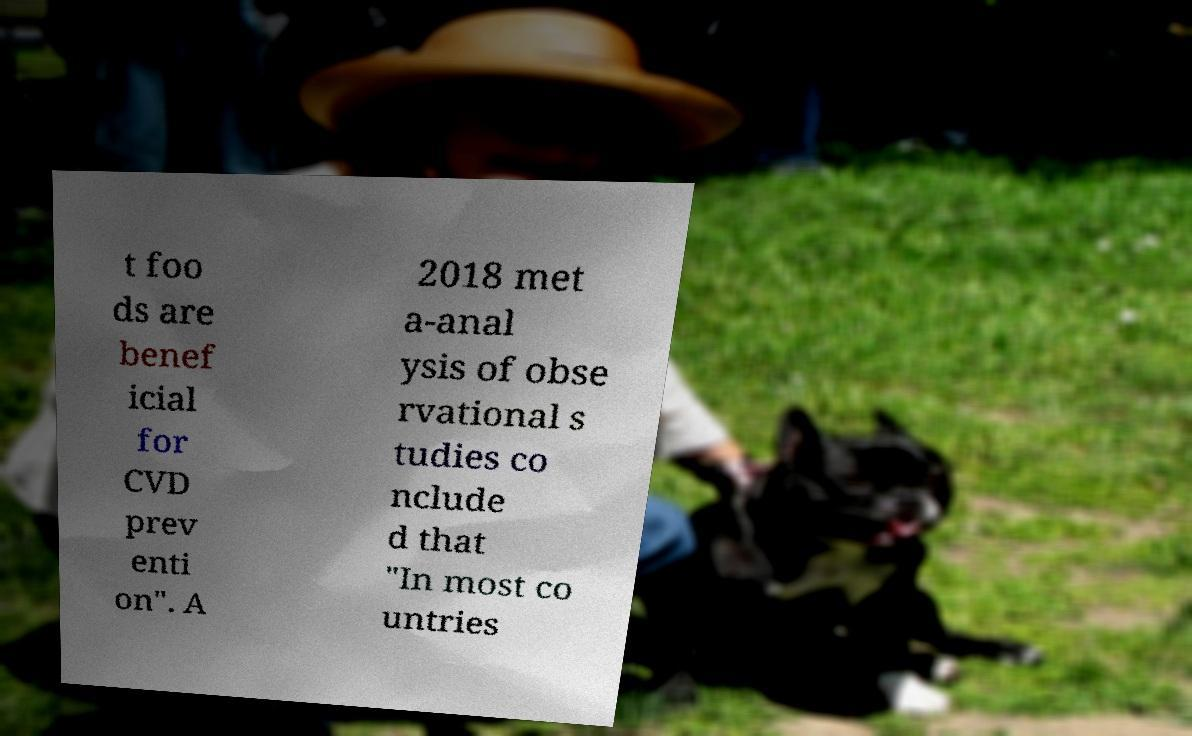What messages or text are displayed in this image? I need them in a readable, typed format. t foo ds are benef icial for CVD prev enti on". A 2018 met a-anal ysis of obse rvational s tudies co nclude d that "In most co untries 